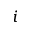<formula> <loc_0><loc_0><loc_500><loc_500>i</formula> 